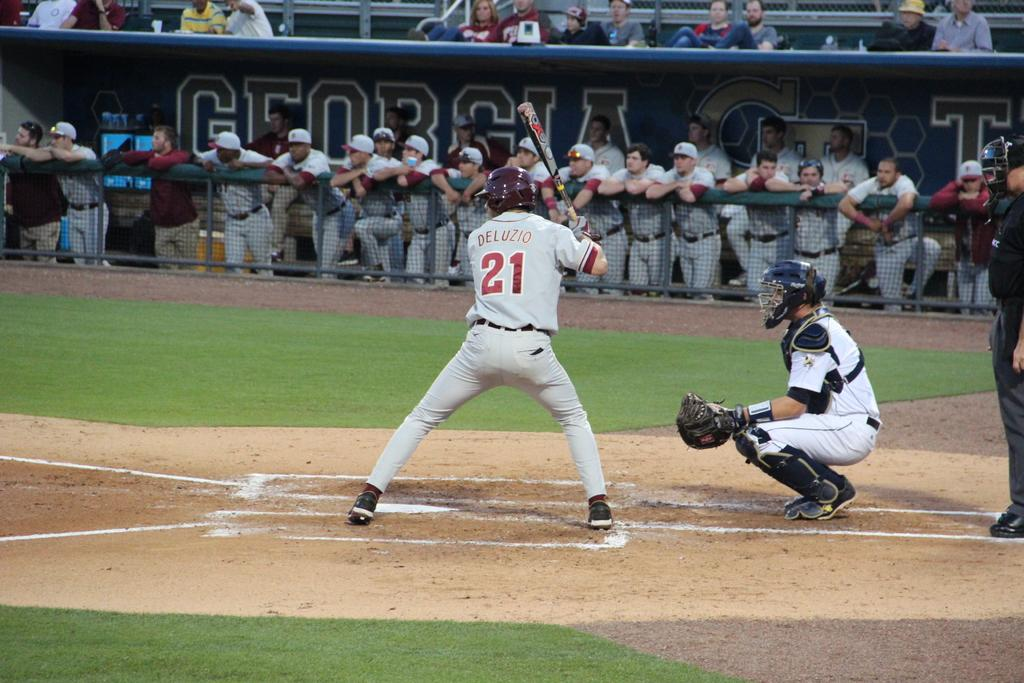<image>
Give a short and clear explanation of the subsequent image. A baseball player has the number 21 on the back of his jersey. 